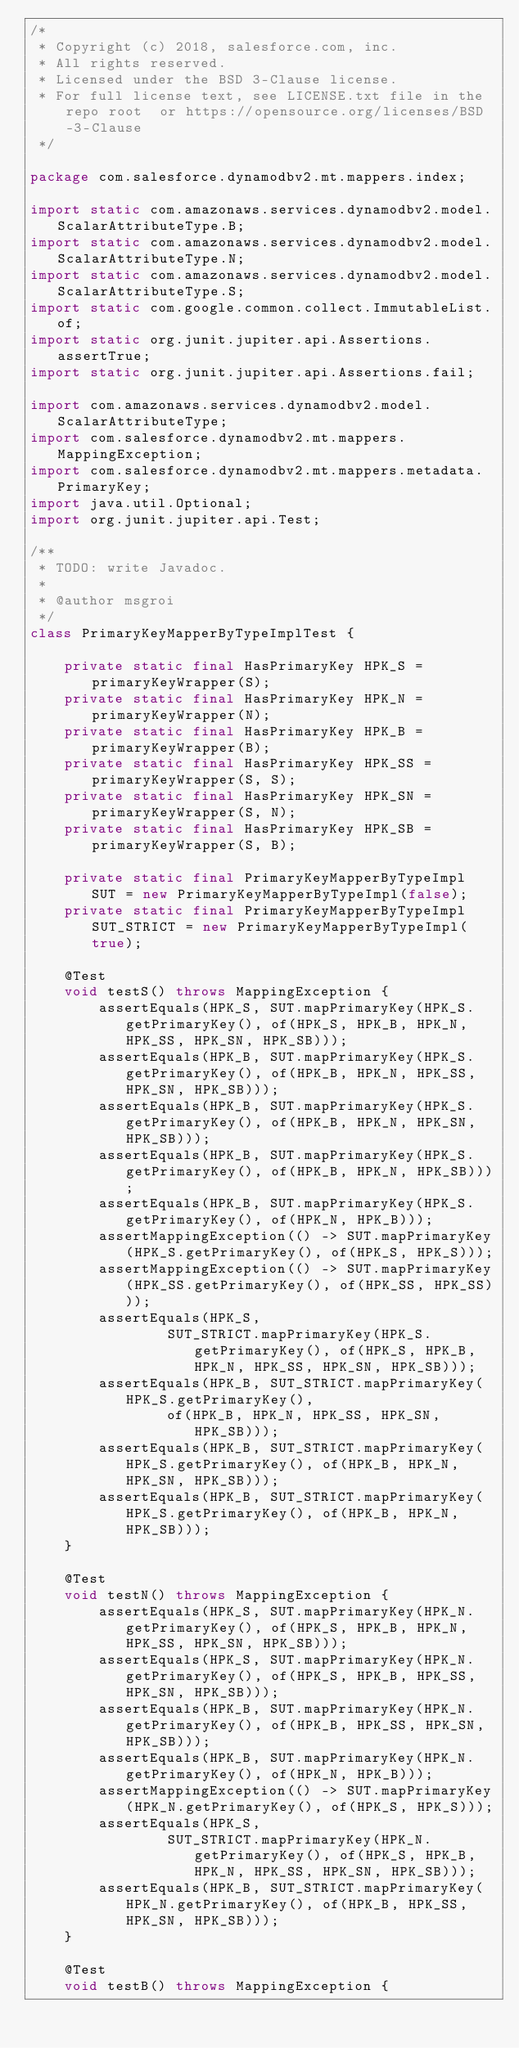Convert code to text. <code><loc_0><loc_0><loc_500><loc_500><_Java_>/*
 * Copyright (c) 2018, salesforce.com, inc.
 * All rights reserved.
 * Licensed under the BSD 3-Clause license.
 * For full license text, see LICENSE.txt file in the repo root  or https://opensource.org/licenses/BSD-3-Clause
 */

package com.salesforce.dynamodbv2.mt.mappers.index;

import static com.amazonaws.services.dynamodbv2.model.ScalarAttributeType.B;
import static com.amazonaws.services.dynamodbv2.model.ScalarAttributeType.N;
import static com.amazonaws.services.dynamodbv2.model.ScalarAttributeType.S;
import static com.google.common.collect.ImmutableList.of;
import static org.junit.jupiter.api.Assertions.assertTrue;
import static org.junit.jupiter.api.Assertions.fail;

import com.amazonaws.services.dynamodbv2.model.ScalarAttributeType;
import com.salesforce.dynamodbv2.mt.mappers.MappingException;
import com.salesforce.dynamodbv2.mt.mappers.metadata.PrimaryKey;
import java.util.Optional;
import org.junit.jupiter.api.Test;

/**
 * TODO: write Javadoc.
 *
 * @author msgroi
 */
class PrimaryKeyMapperByTypeImplTest {

    private static final HasPrimaryKey HPK_S = primaryKeyWrapper(S);
    private static final HasPrimaryKey HPK_N = primaryKeyWrapper(N);
    private static final HasPrimaryKey HPK_B = primaryKeyWrapper(B);
    private static final HasPrimaryKey HPK_SS = primaryKeyWrapper(S, S);
    private static final HasPrimaryKey HPK_SN = primaryKeyWrapper(S, N);
    private static final HasPrimaryKey HPK_SB = primaryKeyWrapper(S, B);

    private static final PrimaryKeyMapperByTypeImpl SUT = new PrimaryKeyMapperByTypeImpl(false);
    private static final PrimaryKeyMapperByTypeImpl SUT_STRICT = new PrimaryKeyMapperByTypeImpl(true);

    @Test
    void testS() throws MappingException {
        assertEquals(HPK_S, SUT.mapPrimaryKey(HPK_S.getPrimaryKey(), of(HPK_S, HPK_B, HPK_N, HPK_SS, HPK_SN, HPK_SB)));
        assertEquals(HPK_B, SUT.mapPrimaryKey(HPK_S.getPrimaryKey(), of(HPK_B, HPK_N, HPK_SS, HPK_SN, HPK_SB)));
        assertEquals(HPK_B, SUT.mapPrimaryKey(HPK_S.getPrimaryKey(), of(HPK_B, HPK_N, HPK_SN, HPK_SB)));
        assertEquals(HPK_B, SUT.mapPrimaryKey(HPK_S.getPrimaryKey(), of(HPK_B, HPK_N, HPK_SB)));
        assertEquals(HPK_B, SUT.mapPrimaryKey(HPK_S.getPrimaryKey(), of(HPK_N, HPK_B)));
        assertMappingException(() -> SUT.mapPrimaryKey(HPK_S.getPrimaryKey(), of(HPK_S, HPK_S)));
        assertMappingException(() -> SUT.mapPrimaryKey(HPK_SS.getPrimaryKey(), of(HPK_SS, HPK_SS)));
        assertEquals(HPK_S,
                SUT_STRICT.mapPrimaryKey(HPK_S.getPrimaryKey(), of(HPK_S, HPK_B, HPK_N, HPK_SS, HPK_SN, HPK_SB)));
        assertEquals(HPK_B, SUT_STRICT.mapPrimaryKey(HPK_S.getPrimaryKey(),
                of(HPK_B, HPK_N, HPK_SS, HPK_SN, HPK_SB)));
        assertEquals(HPK_B, SUT_STRICT.mapPrimaryKey(HPK_S.getPrimaryKey(), of(HPK_B, HPK_N, HPK_SN, HPK_SB)));
        assertEquals(HPK_B, SUT_STRICT.mapPrimaryKey(HPK_S.getPrimaryKey(), of(HPK_B, HPK_N, HPK_SB)));
    }

    @Test
    void testN() throws MappingException {
        assertEquals(HPK_S, SUT.mapPrimaryKey(HPK_N.getPrimaryKey(), of(HPK_S, HPK_B, HPK_N, HPK_SS, HPK_SN, HPK_SB)));
        assertEquals(HPK_S, SUT.mapPrimaryKey(HPK_N.getPrimaryKey(), of(HPK_S, HPK_B, HPK_SS, HPK_SN, HPK_SB)));
        assertEquals(HPK_B, SUT.mapPrimaryKey(HPK_N.getPrimaryKey(), of(HPK_B, HPK_SS, HPK_SN, HPK_SB)));
        assertEquals(HPK_B, SUT.mapPrimaryKey(HPK_N.getPrimaryKey(), of(HPK_N, HPK_B)));
        assertMappingException(() -> SUT.mapPrimaryKey(HPK_N.getPrimaryKey(), of(HPK_S, HPK_S)));
        assertEquals(HPK_S,
                SUT_STRICT.mapPrimaryKey(HPK_N.getPrimaryKey(), of(HPK_S, HPK_B, HPK_N, HPK_SS, HPK_SN, HPK_SB)));
        assertEquals(HPK_B, SUT_STRICT.mapPrimaryKey(HPK_N.getPrimaryKey(), of(HPK_B, HPK_SS, HPK_SN, HPK_SB)));
    }

    @Test
    void testB() throws MappingException {</code> 